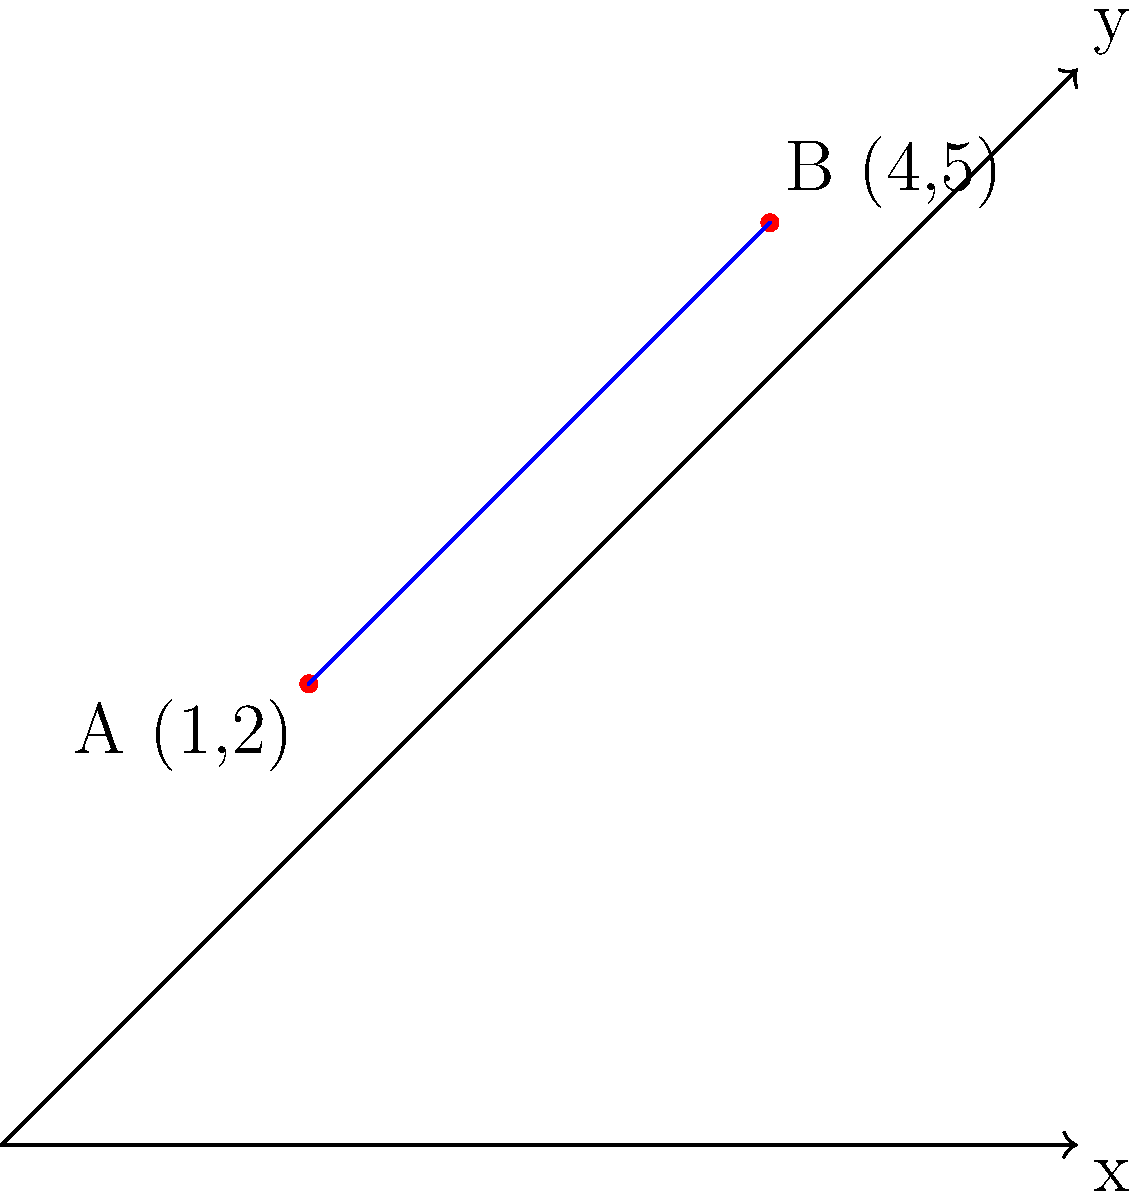In a drug molecule, two functional groups A and B are located at coordinates (1,2) and (4,5) respectively on a 2D plane. Calculate the distance between these two functional groups using the distance formula. Round your answer to two decimal places. To calculate the distance between two points in a 2D plane, we use the distance formula:

$$d = \sqrt{(x_2 - x_1)^2 + (y_2 - y_1)^2}$$

Where $(x_1, y_1)$ are the coordinates of point A and $(x_2, y_2)$ are the coordinates of point B.

Given:
Point A: (1, 2)
Point B: (4, 5)

Step 1: Identify the coordinates
$x_1 = 1, y_1 = 2$
$x_2 = 4, y_2 = 5$

Step 2: Substitute the values into the distance formula
$$d = \sqrt{(4 - 1)^2 + (5 - 2)^2}$$

Step 3: Calculate the differences
$$d = \sqrt{(3)^2 + (3)^2}$$

Step 4: Square the differences
$$d = \sqrt{9 + 9}$$

Step 5: Add the squared differences
$$d = \sqrt{18}$$

Step 6: Calculate the square root
$$d \approx 4.24$$

Step 7: Round to two decimal places
$$d \approx 4.24$$

Therefore, the distance between the two functional groups is approximately 4.24 units.
Answer: 4.24 units 